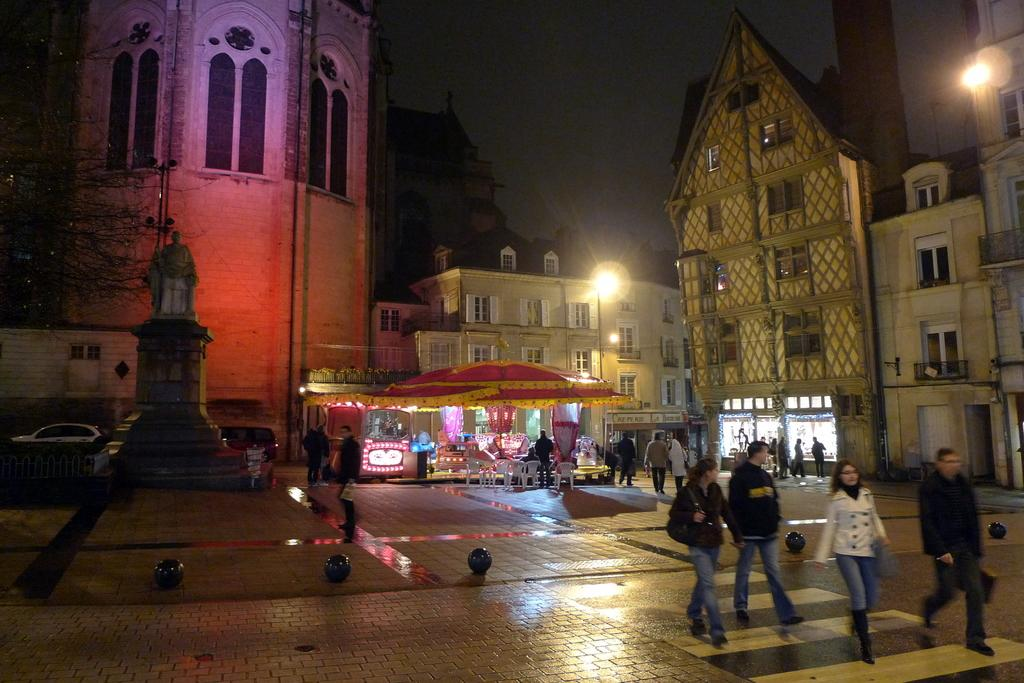What type of structures can be seen in the image? There are many buildings in the image. What is happening in front of the buildings? There are people walking in front of the buildings. Can you describe any other objects or features in the image? There is a sculpture visible in the image. What type of vegetation is present in the image? There are trees in the image. How many flowers are on the head of the person walking in the image? There are no flowers visible on the head of any person walking in the image. 